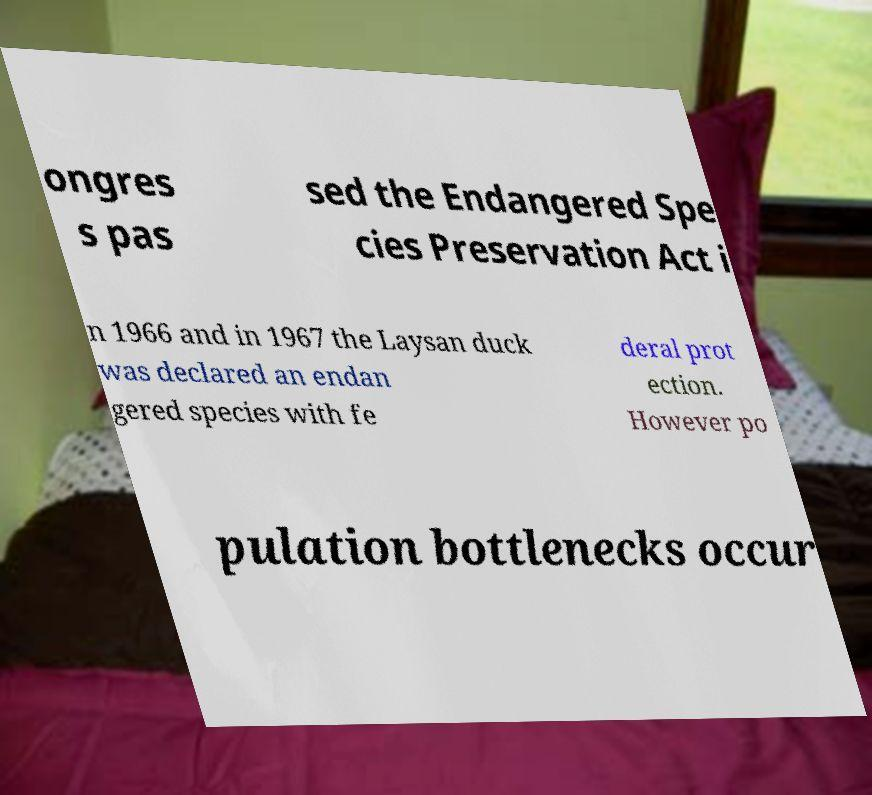Can you accurately transcribe the text from the provided image for me? ongres s pas sed the Endangered Spe cies Preservation Act i n 1966 and in 1967 the Laysan duck was declared an endan gered species with fe deral prot ection. However po pulation bottlenecks occur 